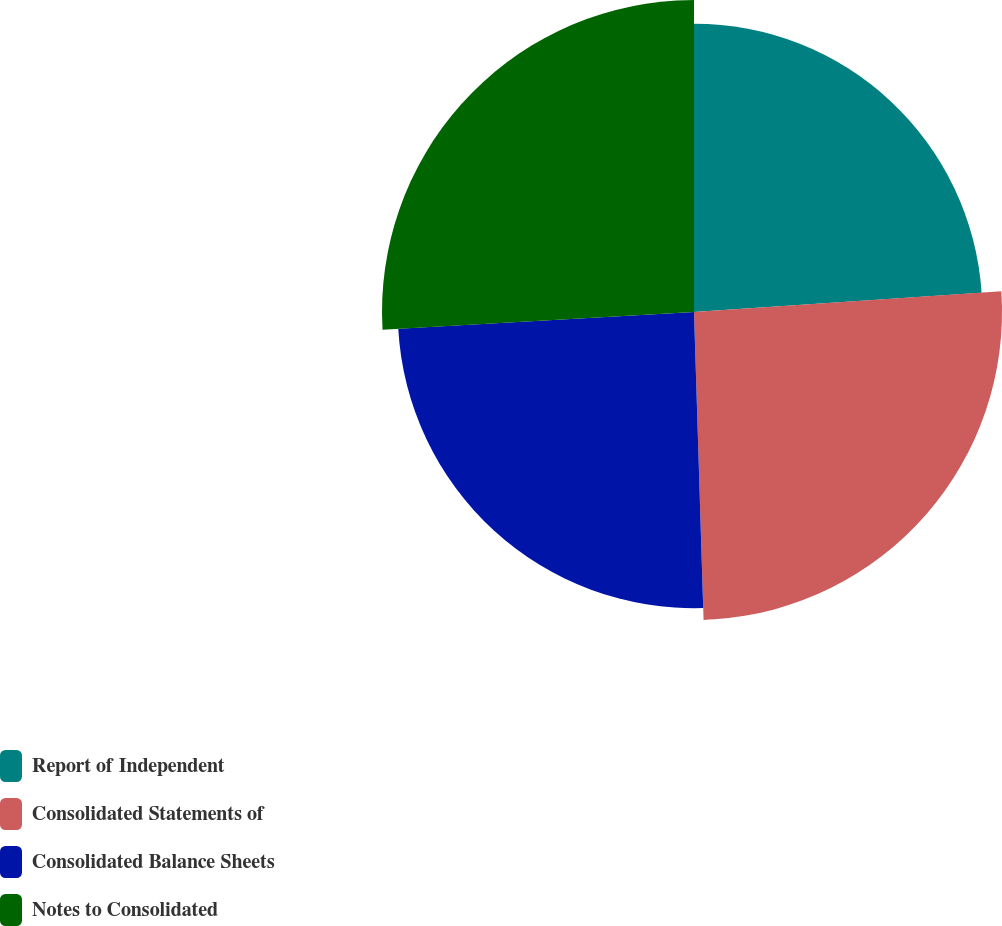<chart> <loc_0><loc_0><loc_500><loc_500><pie_chart><fcel>Report of Independent<fcel>Consolidated Statements of<fcel>Consolidated Balance Sheets<fcel>Notes to Consolidated<nl><fcel>23.93%<fcel>25.57%<fcel>24.59%<fcel>25.9%<nl></chart> 